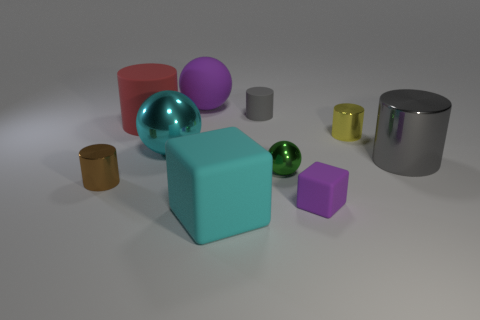Is the number of large shiny spheres on the right side of the yellow shiny thing less than the number of big things left of the large gray cylinder?
Provide a succinct answer. Yes. Is there anything else that is the same color as the large metallic cylinder?
Ensure brevity in your answer.  Yes. The big cyan metallic object has what shape?
Your response must be concise. Sphere. What color is the big sphere that is the same material as the tiny yellow object?
Offer a terse response. Cyan. Is the number of big metallic things greater than the number of big green cubes?
Provide a short and direct response. Yes. Are there any gray rubber things?
Your answer should be very brief. Yes. There is a cyan object in front of the large gray metal thing that is behind the brown thing; what is its shape?
Ensure brevity in your answer.  Cube. What number of things are either large cyan metal things or shiny objects that are right of the large cyan ball?
Provide a short and direct response. 4. There is a big cylinder to the right of the cube to the right of the tiny rubber object that is behind the red cylinder; what is its color?
Your answer should be compact. Gray. There is a tiny thing that is the same shape as the large cyan metallic thing; what is its material?
Give a very brief answer. Metal. 